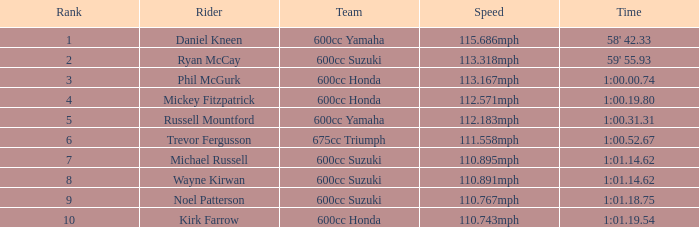How many ranks have 1:01.14.62 as the time, with michael russell as the rider? 1.0. 